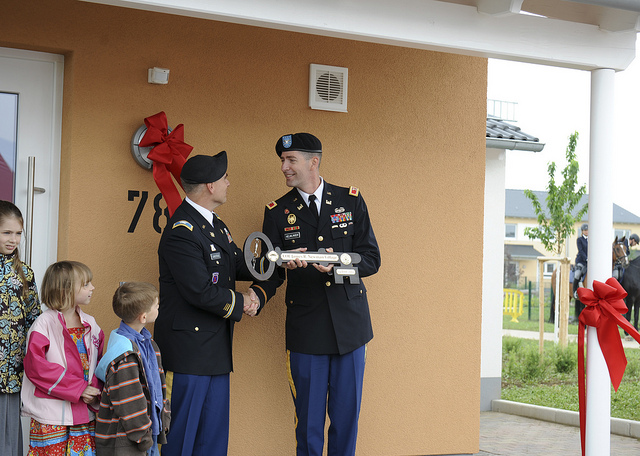<image>What branch of the armed forces are these men in? I am not sure what branch of the armed forces these men are in. It could be marines, navy or the air force. What branch of the armed forces are these men in? I am not sure what branch of the armed forces these men are in. It can be seen 'marines', 'air force', 'army', 'navy' or 'not sure'. 